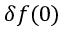Convert formula to latex. <formula><loc_0><loc_0><loc_500><loc_500>\delta f ( 0 )</formula> 